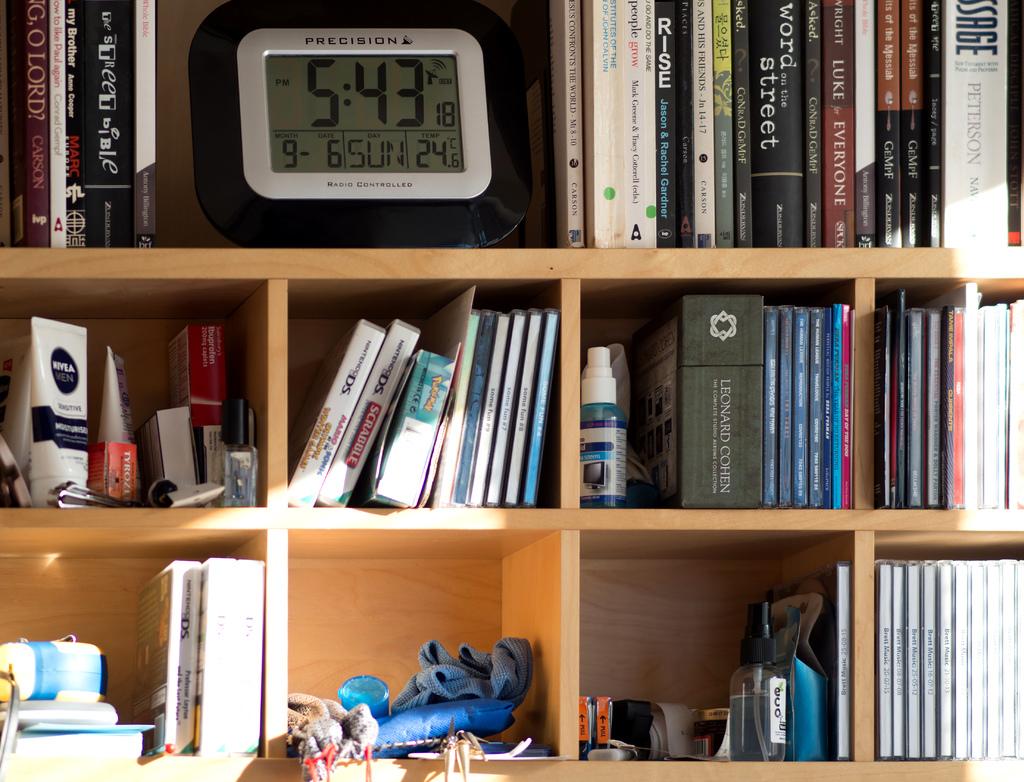What time is it?
Offer a very short reply. 5:43. What day is it,according to the clock?
Give a very brief answer. Sunday. 